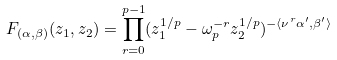Convert formula to latex. <formula><loc_0><loc_0><loc_500><loc_500>F _ { ( \alpha , \beta ) } ( z _ { 1 } , z _ { 2 } ) = \prod _ { r = 0 } ^ { p - 1 } ( z _ { 1 } ^ { 1 / p } - \omega ^ { - r } _ { p } z _ { 2 } ^ { 1 / p } ) ^ { - \langle \nu ^ { r } \alpha ^ { \prime } , \beta ^ { \prime } \rangle }</formula> 